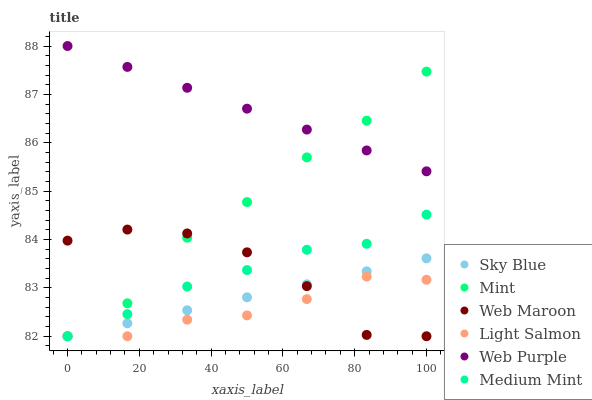Does Light Salmon have the minimum area under the curve?
Answer yes or no. Yes. Does Web Purple have the maximum area under the curve?
Answer yes or no. Yes. Does Web Maroon have the minimum area under the curve?
Answer yes or no. No. Does Web Maroon have the maximum area under the curve?
Answer yes or no. No. Is Web Purple the smoothest?
Answer yes or no. Yes. Is Web Maroon the roughest?
Answer yes or no. Yes. Is Light Salmon the smoothest?
Answer yes or no. No. Is Light Salmon the roughest?
Answer yes or no. No. Does Medium Mint have the lowest value?
Answer yes or no. Yes. Does Web Purple have the lowest value?
Answer yes or no. No. Does Web Purple have the highest value?
Answer yes or no. Yes. Does Web Maroon have the highest value?
Answer yes or no. No. Is Web Maroon less than Web Purple?
Answer yes or no. Yes. Is Web Purple greater than Sky Blue?
Answer yes or no. Yes. Does Mint intersect Medium Mint?
Answer yes or no. Yes. Is Mint less than Medium Mint?
Answer yes or no. No. Is Mint greater than Medium Mint?
Answer yes or no. No. Does Web Maroon intersect Web Purple?
Answer yes or no. No. 